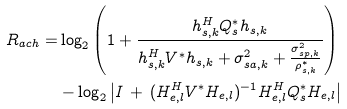<formula> <loc_0><loc_0><loc_500><loc_500>R _ { a c h } = & \log _ { 2 } \left ( 1 + \frac { h _ { s , k } ^ { H } Q ^ { * } _ { s } h _ { s , k } } { h _ { s , k } ^ { H } V ^ { * } h _ { s , k } + \sigma _ { s a , k } ^ { 2 } + \frac { \sigma _ { s p , k } ^ { 2 } } { \rho ^ { * } _ { s , k } } } \right ) \\ & - \log _ { 2 } \left | I \, + \, ( H _ { e , l } ^ { H } V ^ { * } H _ { e , l } ) ^ { - 1 } H _ { e , l } ^ { H } Q ^ { * } _ { s } H _ { e , l } \right |</formula> 